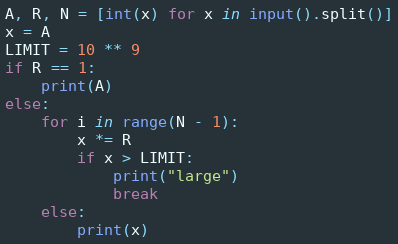Convert code to text. <code><loc_0><loc_0><loc_500><loc_500><_Python_>A, R, N = [int(x) for x in input().split()]
x = A
LIMIT = 10 ** 9
if R == 1:
    print(A)
else:
    for i in range(N - 1):
        x *= R
        if x > LIMIT:
            print("large")
            break
    else:
        print(x)
</code> 